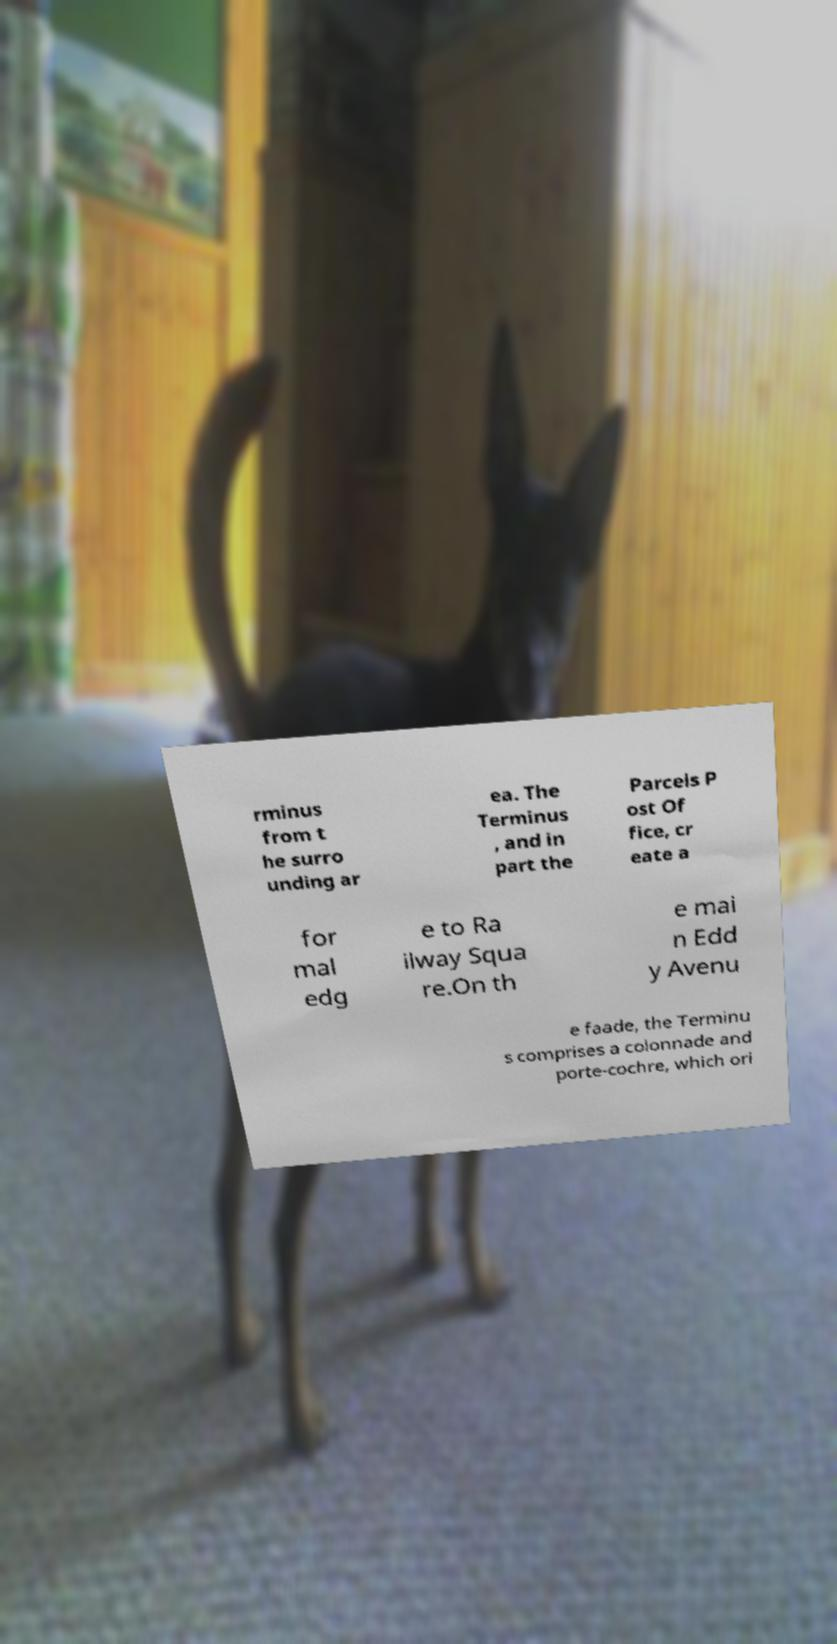For documentation purposes, I need the text within this image transcribed. Could you provide that? rminus from t he surro unding ar ea. The Terminus , and in part the Parcels P ost Of fice, cr eate a for mal edg e to Ra ilway Squa re.On th e mai n Edd y Avenu e faade, the Terminu s comprises a colonnade and porte-cochre, which ori 